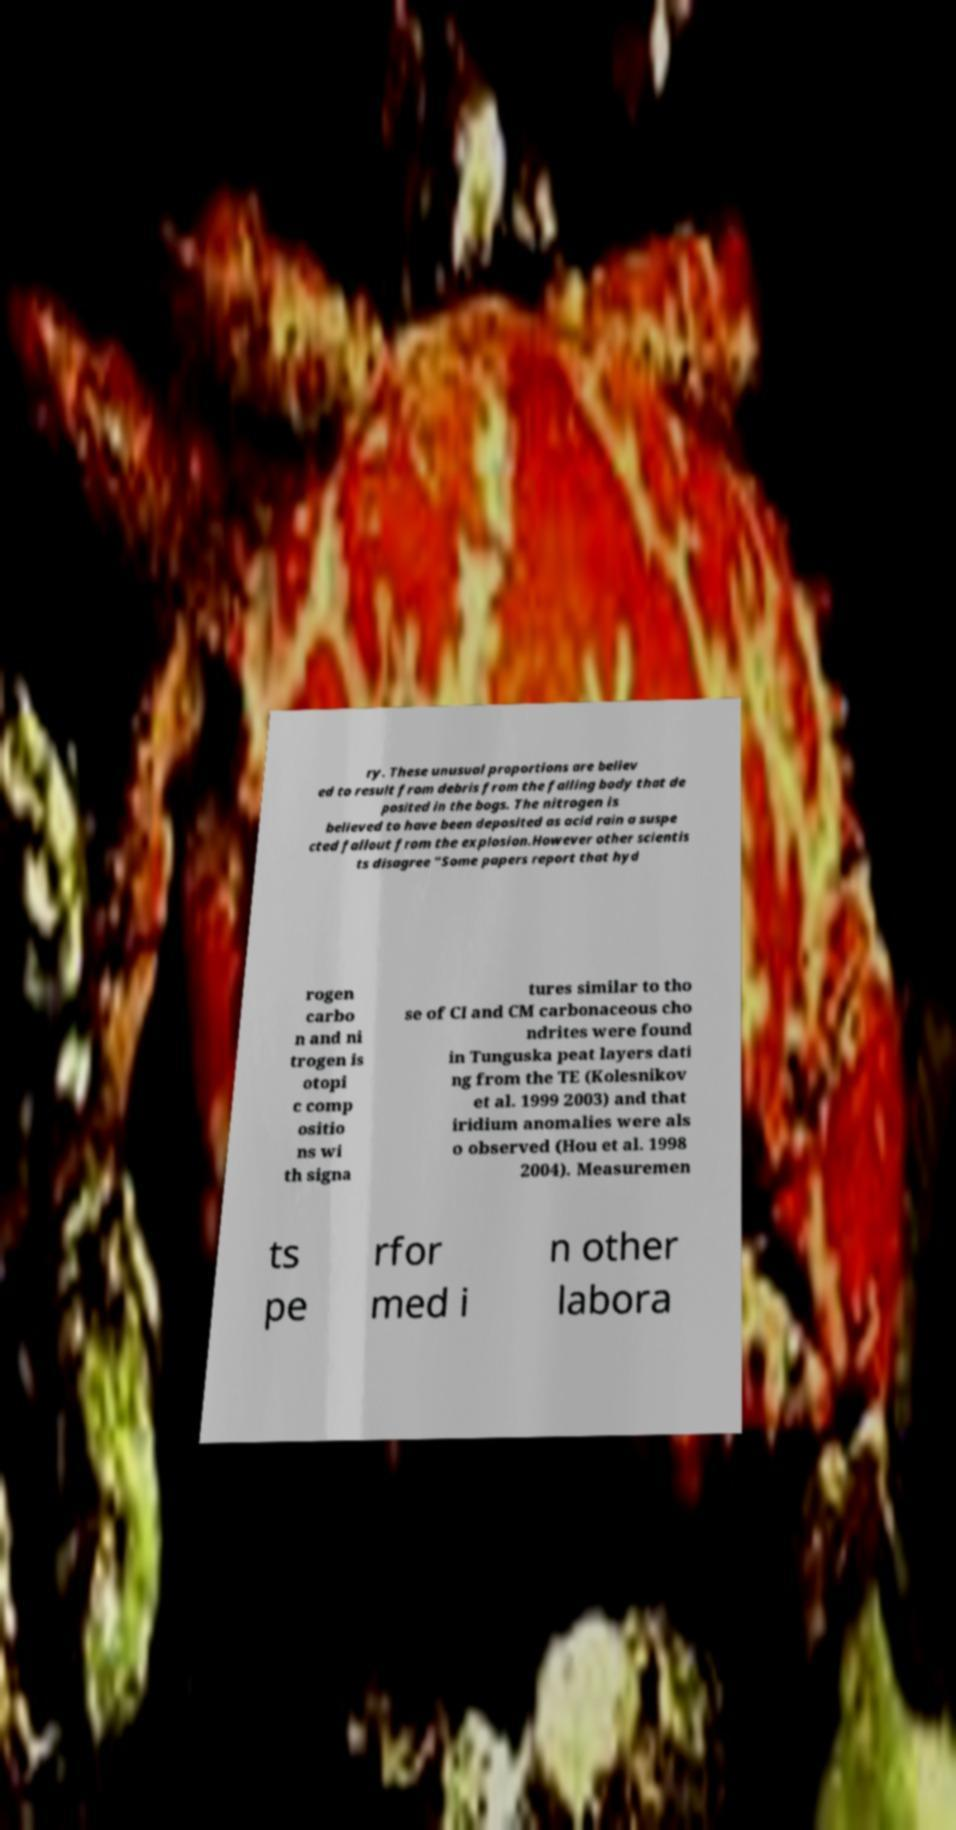I need the written content from this picture converted into text. Can you do that? ry. These unusual proportions are believ ed to result from debris from the falling body that de posited in the bogs. The nitrogen is believed to have been deposited as acid rain a suspe cted fallout from the explosion.However other scientis ts disagree "Some papers report that hyd rogen carbo n and ni trogen is otopi c comp ositio ns wi th signa tures similar to tho se of CI and CM carbonaceous cho ndrites were found in Tunguska peat layers dati ng from the TE (Kolesnikov et al. 1999 2003) and that iridium anomalies were als o observed (Hou et al. 1998 2004). Measuremen ts pe rfor med i n other labora 